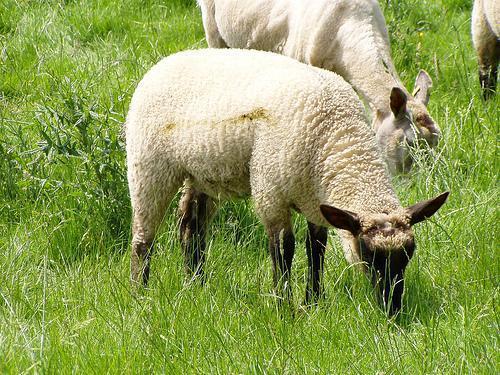How many sheep?
Give a very brief answer. 3. How many ears are shown?
Give a very brief answer. 4. How many sheeps has a long stain on his body?
Give a very brief answer. 1. 